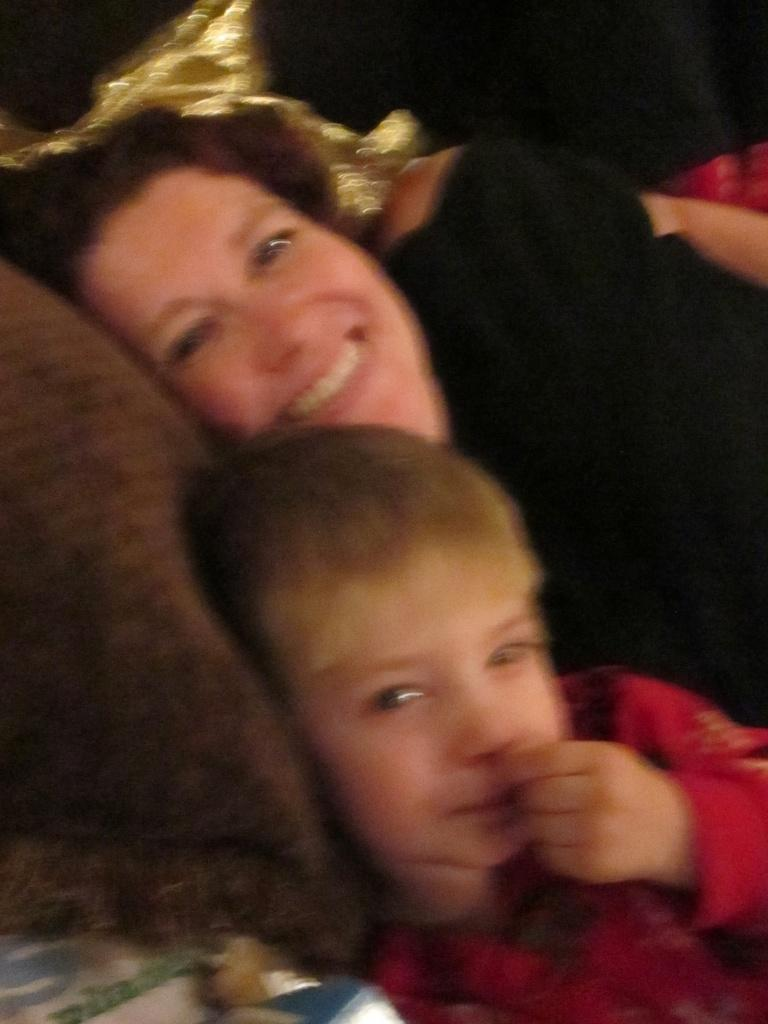Who is present in the image? There is a lady and a kid in the image. What are they doing in the image? Both the lady and the kid are lying on the bed. What can be seen on the bed? There is a pillow in the image. What type of tax is being discussed by the lady and the kid in the image? There is no indication in the image that the lady and the kid are discussing any type of tax. 